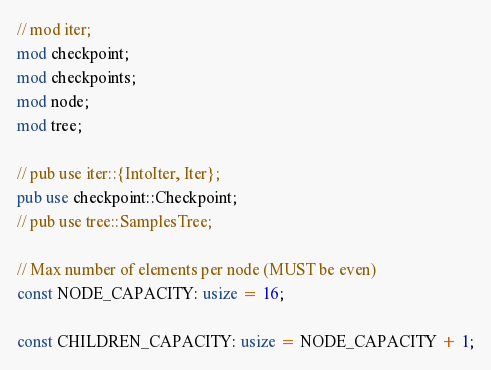Convert code to text. <code><loc_0><loc_0><loc_500><loc_500><_Rust_>// mod iter;
mod checkpoint;
mod checkpoints;
mod node;
mod tree;

// pub use iter::{IntoIter, Iter};
pub use checkpoint::Checkpoint;
// pub use tree::SamplesTree;

// Max number of elements per node (MUST be even)
const NODE_CAPACITY: usize = 16;

const CHILDREN_CAPACITY: usize = NODE_CAPACITY + 1;
</code> 